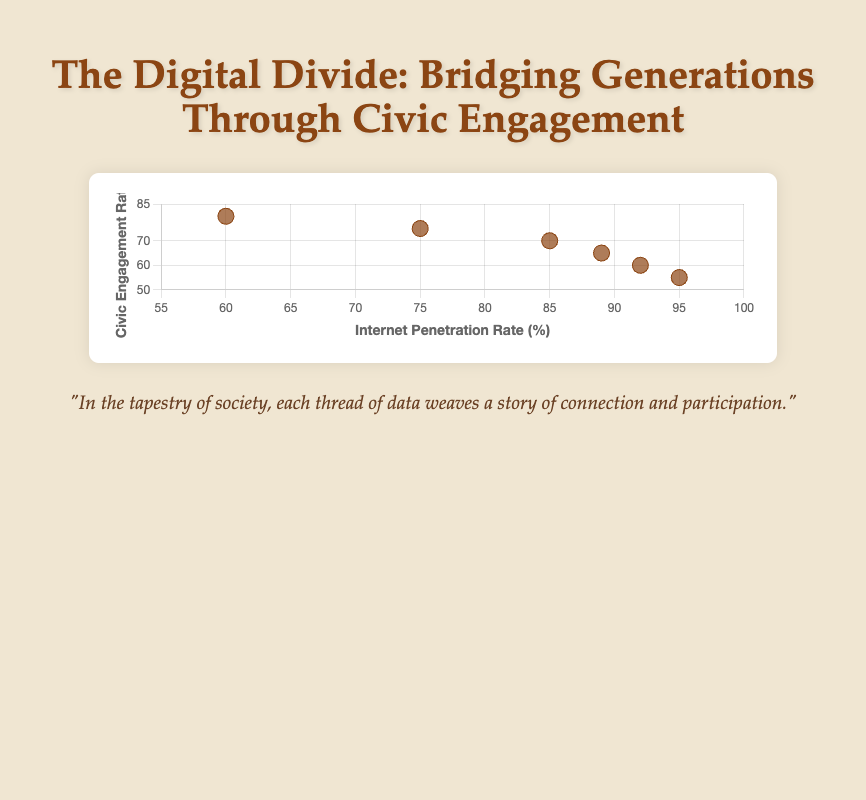what is the title of the figure? The title is located at the top of the figure and reads, "The Digital Divide: Bridging Generations Through Civic Engagement."
Answer: The Digital Divide: Bridging Generations Through Civic Engagement how many age groups are represented in the figure? By counting the distinct data points or labels in the figure, there are 6 age groups displayed under the axis and tooltip.
Answer: 6 which age group has the highest internet penetration rate? The tooltip or x-axis data can be used to identify that the "18-24" age group has the highest internet penetration rate of 95%.
Answer: 18-24 what are the axis titles on the x and y axes? The x-axis and y-axis titles are directly visible at the ends of each axis, labeled "Internet Penetration Rate (%)" and "Civic Engagement Rate (%)" respectively.
Answer: Internet Penetration Rate (%); Civic Engagement Rate (%) how does civic engagement rate trend with decreasing internet penetration rate? Observing the scatter plot, as internet penetration rate decreases from left to right, the civic engagement rate generally increases, showing a negative correlation.
Answer: increases which age group shows the highest civic engagement rate, and what is it? By looking at the y-axis or tooltip, the age group "65+" shows the highest civic engagement rate, which is 80%.
Answer: 65+; 80% is there a negative or positive correlation between internet penetration rate and civic engagement rate? The scatter plot shows a clear trend that as the internet penetration rate decreases, civic engagement rate increases, indicating a negative correlation.
Answer: negative what is the average internet penetration rate of all age groups combined? Sum all internet penetration rates (95+92+89+85+75+60) = 496, then divide by the number of age groups (6), yielding an average rate of 82.67%.
Answer: 82.67% which age group shows the largest difference between internet penetration rate and civic engagement rate? Calculate the absolute differences for each age group: 18-24: 40, 25-34: 32, 35-44: 24, 45-54: 15, 55-64: 0, 65+: -20. The largest difference is for "18-24" with a difference of 40.
Answer: 18-24 